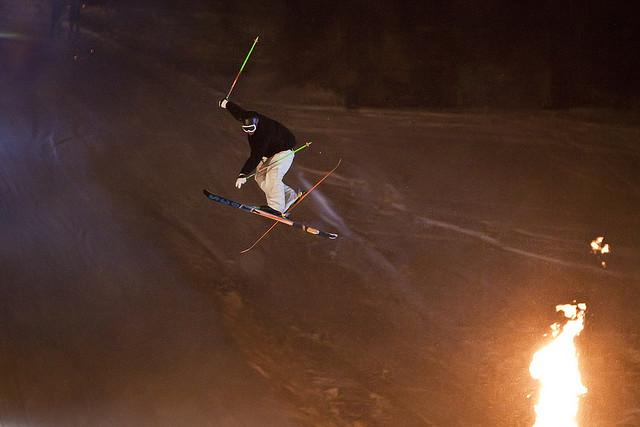Is the man skiing at night?
Give a very brief answer. Yes. Is there fire in the picture?
Keep it brief. Yes. What is the man doing?
Write a very short answer. Skiing. 